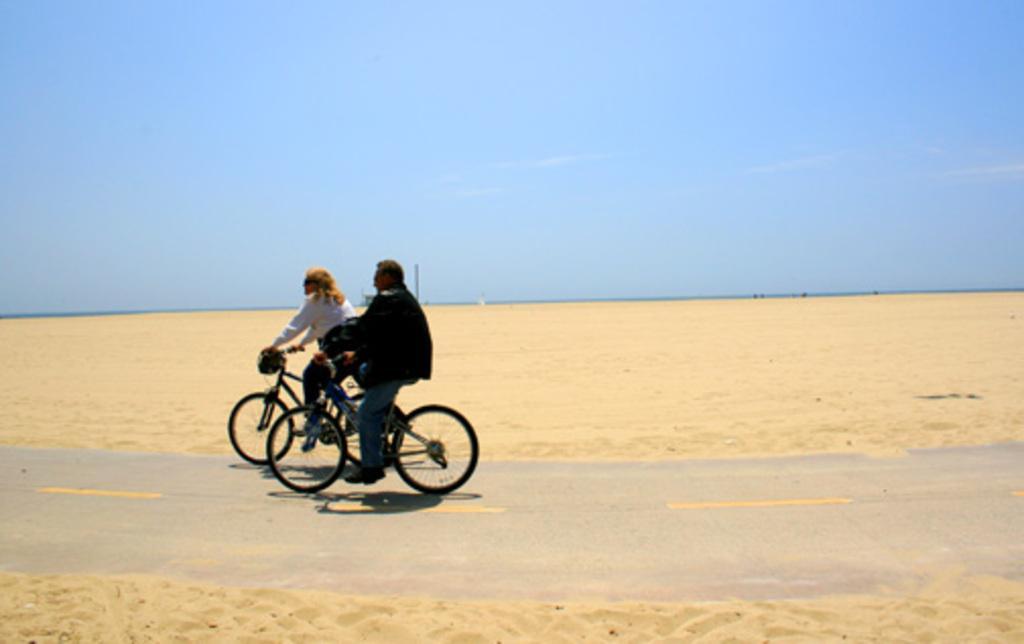In one or two sentences, can you explain what this image depicts? In this image I can see two persons riding bicycles. In the background I can see the pole, sand and the sky is in blue color. 